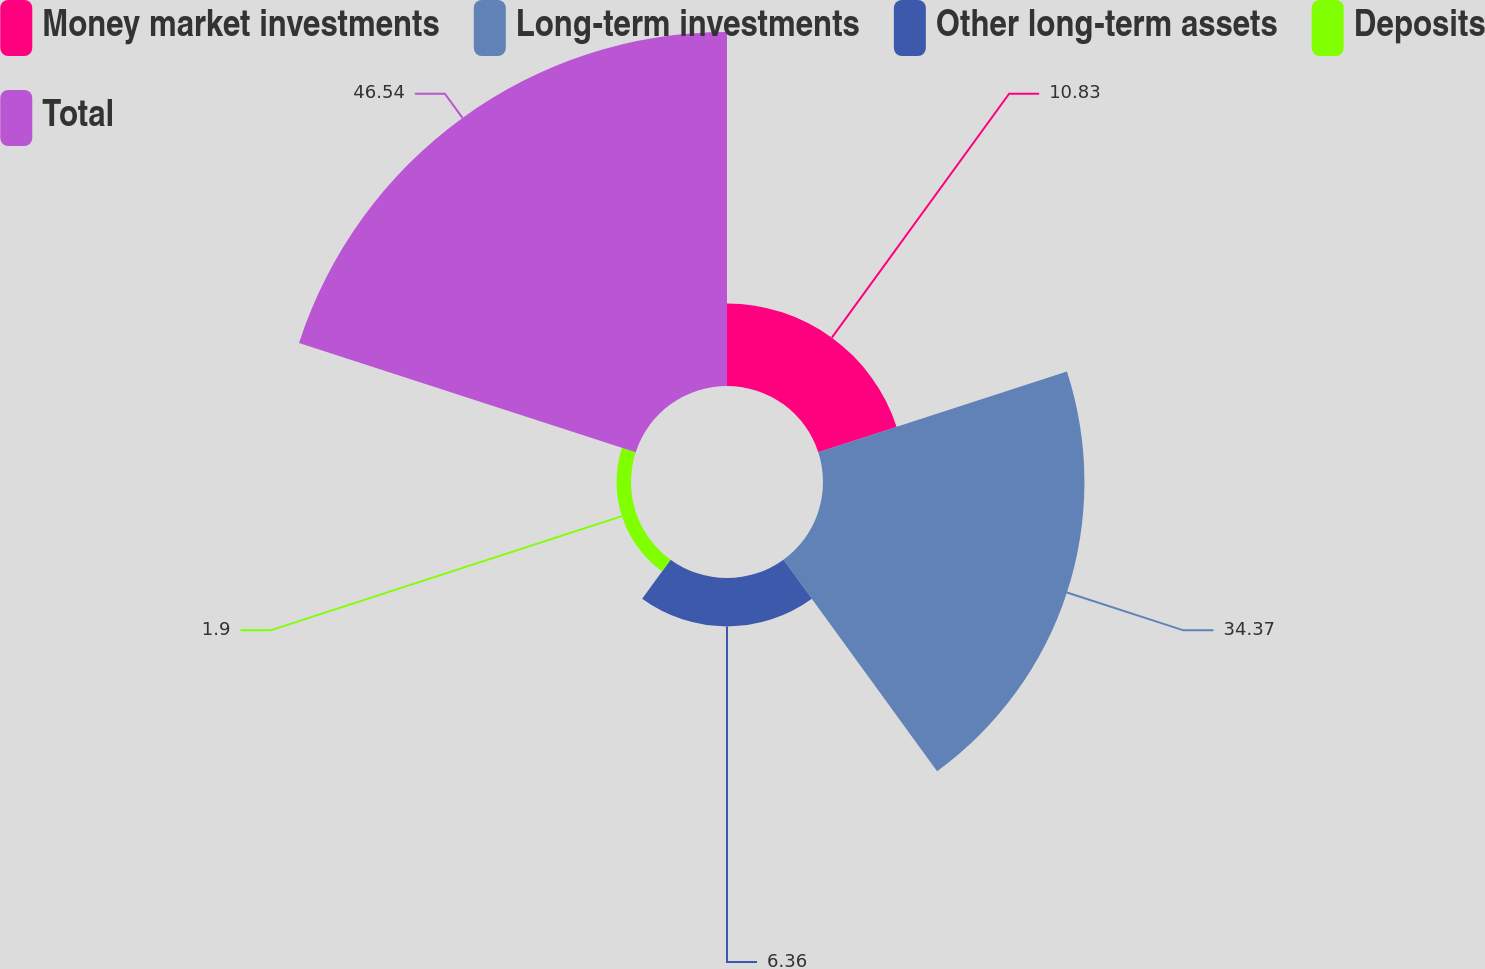Convert chart to OTSL. <chart><loc_0><loc_0><loc_500><loc_500><pie_chart><fcel>Money market investments<fcel>Long-term investments<fcel>Other long-term assets<fcel>Deposits<fcel>Total<nl><fcel>10.83%<fcel>34.37%<fcel>6.36%<fcel>1.9%<fcel>46.54%<nl></chart> 